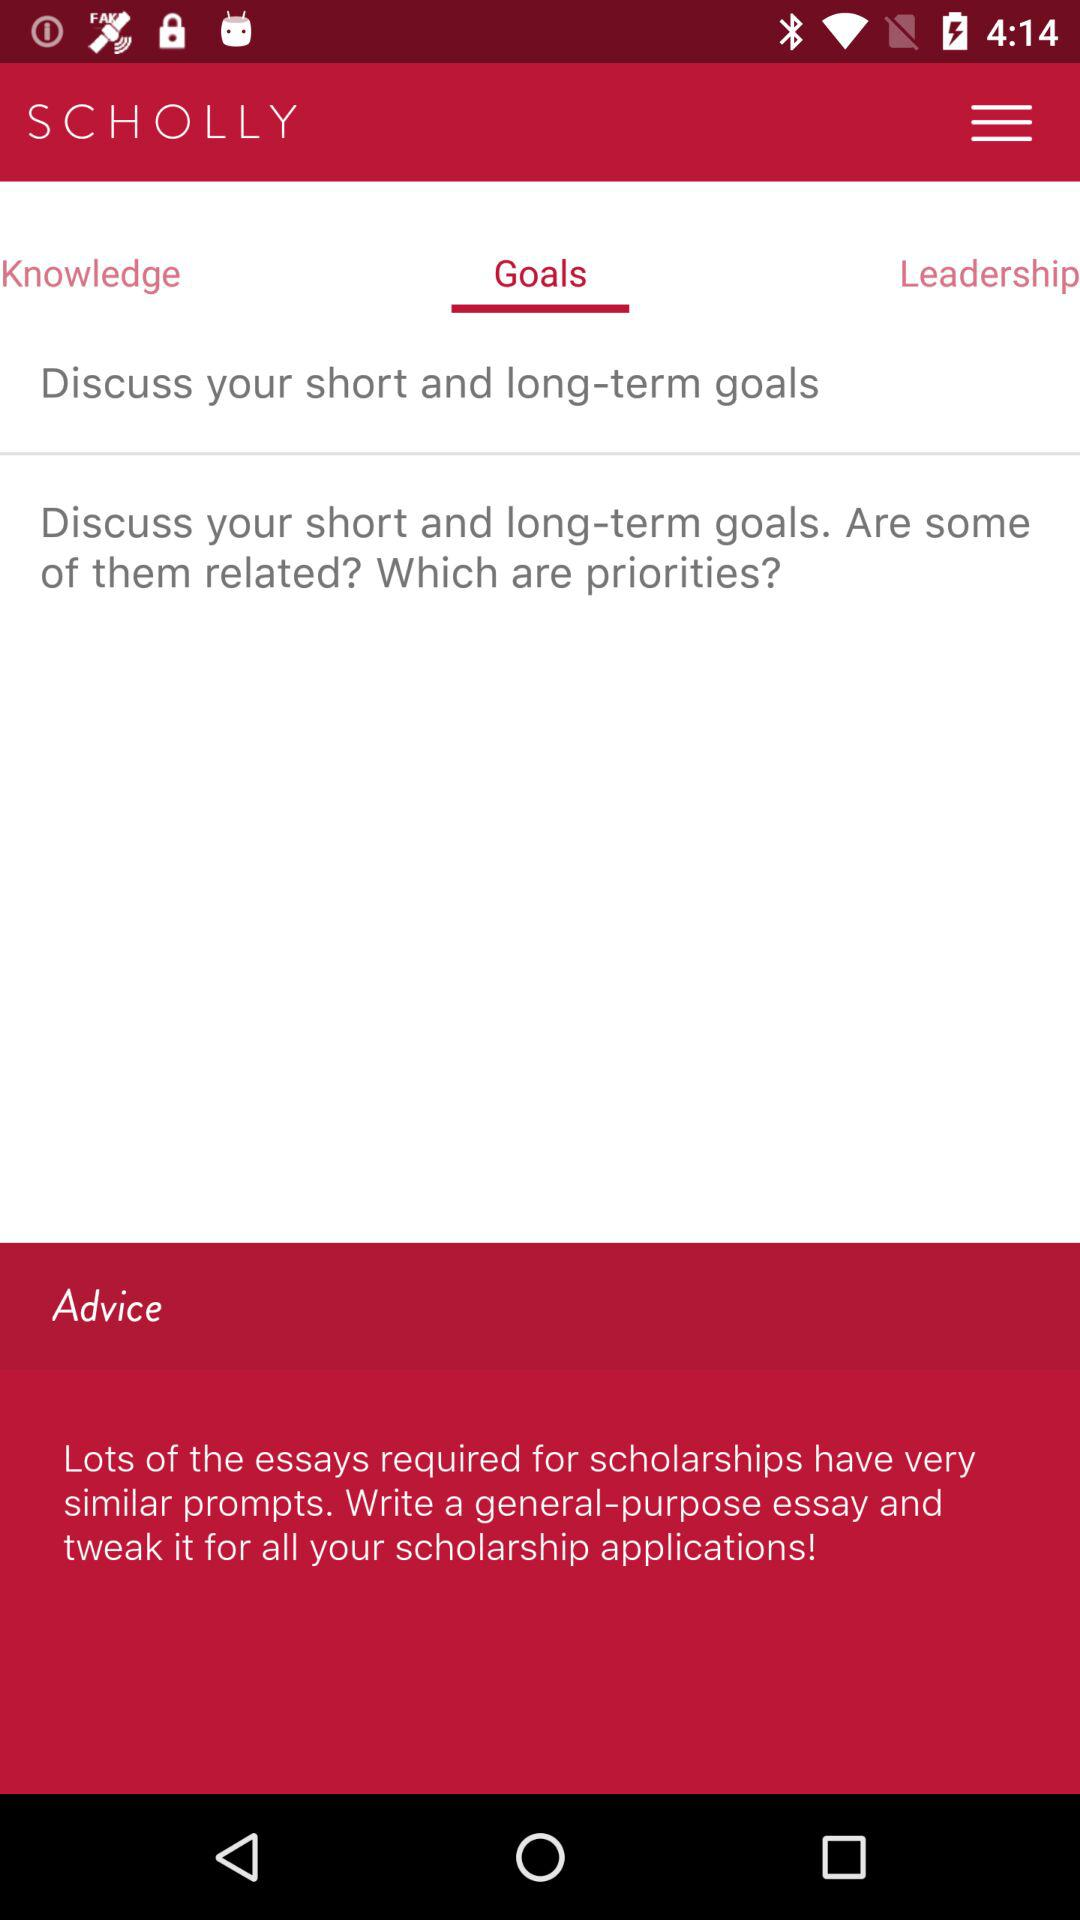What is the application name? The application name is "SCHOLLY". 